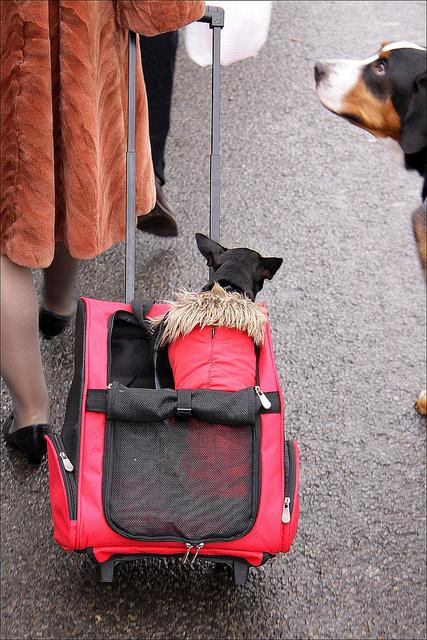What type of shoes does the woman have on? Please explain your reasoning. high heels. The woman has high heels on. 